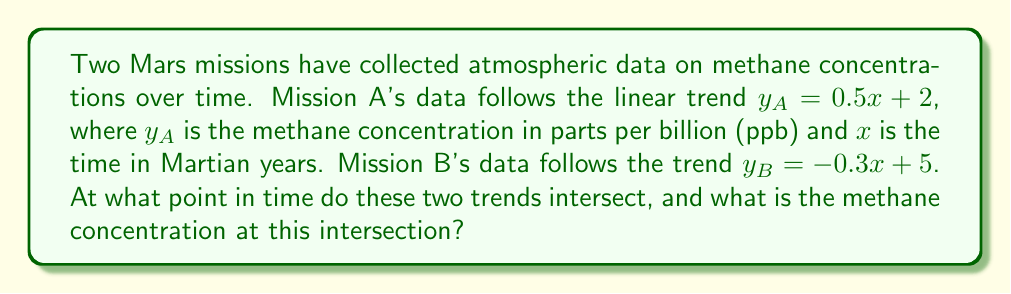Could you help me with this problem? To find the intersection point of these two linear trends, we need to solve the system of equations:

$$\begin{cases}
y_A = 0.5x + 2 \\
y_B = -0.3x + 5
\end{cases}$$

At the intersection point, $y_A = y_B$, so we can set the equations equal to each other:

$$0.5x + 2 = -0.3x + 5$$

Now, let's solve for $x$:

1) Add $0.3x$ to both sides:
   $$0.8x + 2 = 5$$

2) Subtract 2 from both sides:
   $$0.8x = 3$$

3) Divide both sides by 0.8:
   $$x = \frac{3}{0.8} = 3.75$$

So, the intersection occurs at $x = 3.75$ Martian years.

To find the methane concentration at this point, we can substitute $x = 3.75$ into either of the original equations. Let's use Mission A's equation:

$$y_A = 0.5(3.75) + 2 = 1.875 + 2 = 3.875$$

Therefore, the intersection point occurs at (3.75, 3.875), where 3.75 represents the time in Martian years, and 3.875 represents the methane concentration in ppb.
Answer: (3.75, 3.875) 